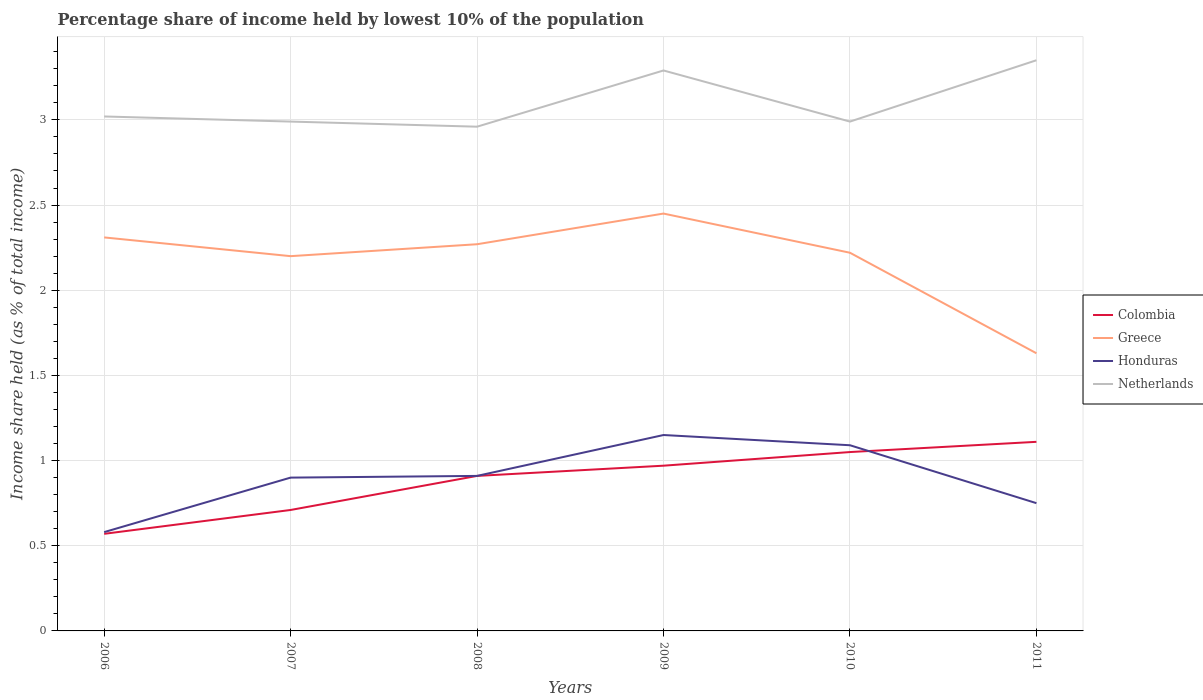Across all years, what is the maximum percentage share of income held by lowest 10% of the population in Colombia?
Make the answer very short. 0.57. What is the total percentage share of income held by lowest 10% of the population in Netherlands in the graph?
Provide a succinct answer. -0.36. What is the difference between the highest and the second highest percentage share of income held by lowest 10% of the population in Greece?
Give a very brief answer. 0.82. What is the difference between two consecutive major ticks on the Y-axis?
Keep it short and to the point. 0.5. Are the values on the major ticks of Y-axis written in scientific E-notation?
Provide a short and direct response. No. Does the graph contain any zero values?
Your response must be concise. No. Where does the legend appear in the graph?
Give a very brief answer. Center right. How many legend labels are there?
Make the answer very short. 4. What is the title of the graph?
Offer a very short reply. Percentage share of income held by lowest 10% of the population. What is the label or title of the Y-axis?
Your response must be concise. Income share held (as % of total income). What is the Income share held (as % of total income) of Colombia in 2006?
Offer a very short reply. 0.57. What is the Income share held (as % of total income) in Greece in 2006?
Offer a terse response. 2.31. What is the Income share held (as % of total income) in Honduras in 2006?
Your answer should be very brief. 0.58. What is the Income share held (as % of total income) in Netherlands in 2006?
Offer a very short reply. 3.02. What is the Income share held (as % of total income) of Colombia in 2007?
Offer a very short reply. 0.71. What is the Income share held (as % of total income) of Greece in 2007?
Make the answer very short. 2.2. What is the Income share held (as % of total income) in Netherlands in 2007?
Ensure brevity in your answer.  2.99. What is the Income share held (as % of total income) in Colombia in 2008?
Provide a succinct answer. 0.91. What is the Income share held (as % of total income) in Greece in 2008?
Provide a short and direct response. 2.27. What is the Income share held (as % of total income) in Honduras in 2008?
Give a very brief answer. 0.91. What is the Income share held (as % of total income) of Netherlands in 2008?
Your answer should be compact. 2.96. What is the Income share held (as % of total income) in Greece in 2009?
Keep it short and to the point. 2.45. What is the Income share held (as % of total income) of Honduras in 2009?
Offer a terse response. 1.15. What is the Income share held (as % of total income) of Netherlands in 2009?
Offer a terse response. 3.29. What is the Income share held (as % of total income) of Greece in 2010?
Keep it short and to the point. 2.22. What is the Income share held (as % of total income) in Honduras in 2010?
Your response must be concise. 1.09. What is the Income share held (as % of total income) of Netherlands in 2010?
Keep it short and to the point. 2.99. What is the Income share held (as % of total income) of Colombia in 2011?
Your answer should be compact. 1.11. What is the Income share held (as % of total income) of Greece in 2011?
Make the answer very short. 1.63. What is the Income share held (as % of total income) of Netherlands in 2011?
Your answer should be compact. 3.35. Across all years, what is the maximum Income share held (as % of total income) of Colombia?
Your answer should be compact. 1.11. Across all years, what is the maximum Income share held (as % of total income) of Greece?
Offer a terse response. 2.45. Across all years, what is the maximum Income share held (as % of total income) in Honduras?
Offer a very short reply. 1.15. Across all years, what is the maximum Income share held (as % of total income) in Netherlands?
Offer a very short reply. 3.35. Across all years, what is the minimum Income share held (as % of total income) of Colombia?
Make the answer very short. 0.57. Across all years, what is the minimum Income share held (as % of total income) in Greece?
Offer a terse response. 1.63. Across all years, what is the minimum Income share held (as % of total income) of Honduras?
Make the answer very short. 0.58. Across all years, what is the minimum Income share held (as % of total income) in Netherlands?
Your answer should be compact. 2.96. What is the total Income share held (as % of total income) in Colombia in the graph?
Provide a short and direct response. 5.32. What is the total Income share held (as % of total income) in Greece in the graph?
Your response must be concise. 13.08. What is the total Income share held (as % of total income) in Honduras in the graph?
Give a very brief answer. 5.38. What is the total Income share held (as % of total income) of Netherlands in the graph?
Give a very brief answer. 18.6. What is the difference between the Income share held (as % of total income) of Colombia in 2006 and that in 2007?
Provide a short and direct response. -0.14. What is the difference between the Income share held (as % of total income) in Greece in 2006 and that in 2007?
Give a very brief answer. 0.11. What is the difference between the Income share held (as % of total income) in Honduras in 2006 and that in 2007?
Your answer should be compact. -0.32. What is the difference between the Income share held (as % of total income) in Netherlands in 2006 and that in 2007?
Your response must be concise. 0.03. What is the difference between the Income share held (as % of total income) of Colombia in 2006 and that in 2008?
Offer a very short reply. -0.34. What is the difference between the Income share held (as % of total income) in Honduras in 2006 and that in 2008?
Your answer should be very brief. -0.33. What is the difference between the Income share held (as % of total income) of Netherlands in 2006 and that in 2008?
Ensure brevity in your answer.  0.06. What is the difference between the Income share held (as % of total income) of Greece in 2006 and that in 2009?
Your response must be concise. -0.14. What is the difference between the Income share held (as % of total income) of Honduras in 2006 and that in 2009?
Offer a terse response. -0.57. What is the difference between the Income share held (as % of total income) of Netherlands in 2006 and that in 2009?
Provide a succinct answer. -0.27. What is the difference between the Income share held (as % of total income) in Colombia in 2006 and that in 2010?
Your answer should be compact. -0.48. What is the difference between the Income share held (as % of total income) in Greece in 2006 and that in 2010?
Your answer should be compact. 0.09. What is the difference between the Income share held (as % of total income) in Honduras in 2006 and that in 2010?
Ensure brevity in your answer.  -0.51. What is the difference between the Income share held (as % of total income) in Netherlands in 2006 and that in 2010?
Provide a succinct answer. 0.03. What is the difference between the Income share held (as % of total income) in Colombia in 2006 and that in 2011?
Ensure brevity in your answer.  -0.54. What is the difference between the Income share held (as % of total income) of Greece in 2006 and that in 2011?
Offer a very short reply. 0.68. What is the difference between the Income share held (as % of total income) of Honduras in 2006 and that in 2011?
Keep it short and to the point. -0.17. What is the difference between the Income share held (as % of total income) in Netherlands in 2006 and that in 2011?
Provide a short and direct response. -0.33. What is the difference between the Income share held (as % of total income) of Colombia in 2007 and that in 2008?
Give a very brief answer. -0.2. What is the difference between the Income share held (as % of total income) of Greece in 2007 and that in 2008?
Offer a terse response. -0.07. What is the difference between the Income share held (as % of total income) of Honduras in 2007 and that in 2008?
Offer a terse response. -0.01. What is the difference between the Income share held (as % of total income) of Netherlands in 2007 and that in 2008?
Your answer should be compact. 0.03. What is the difference between the Income share held (as % of total income) of Colombia in 2007 and that in 2009?
Your answer should be very brief. -0.26. What is the difference between the Income share held (as % of total income) of Honduras in 2007 and that in 2009?
Provide a succinct answer. -0.25. What is the difference between the Income share held (as % of total income) of Netherlands in 2007 and that in 2009?
Your response must be concise. -0.3. What is the difference between the Income share held (as % of total income) of Colombia in 2007 and that in 2010?
Offer a very short reply. -0.34. What is the difference between the Income share held (as % of total income) in Greece in 2007 and that in 2010?
Make the answer very short. -0.02. What is the difference between the Income share held (as % of total income) in Honduras in 2007 and that in 2010?
Make the answer very short. -0.19. What is the difference between the Income share held (as % of total income) in Netherlands in 2007 and that in 2010?
Your response must be concise. 0. What is the difference between the Income share held (as % of total income) of Greece in 2007 and that in 2011?
Ensure brevity in your answer.  0.57. What is the difference between the Income share held (as % of total income) in Honduras in 2007 and that in 2011?
Give a very brief answer. 0.15. What is the difference between the Income share held (as % of total income) in Netherlands in 2007 and that in 2011?
Ensure brevity in your answer.  -0.36. What is the difference between the Income share held (as % of total income) of Colombia in 2008 and that in 2009?
Ensure brevity in your answer.  -0.06. What is the difference between the Income share held (as % of total income) in Greece in 2008 and that in 2009?
Keep it short and to the point. -0.18. What is the difference between the Income share held (as % of total income) of Honduras in 2008 and that in 2009?
Your answer should be compact. -0.24. What is the difference between the Income share held (as % of total income) of Netherlands in 2008 and that in 2009?
Offer a very short reply. -0.33. What is the difference between the Income share held (as % of total income) of Colombia in 2008 and that in 2010?
Keep it short and to the point. -0.14. What is the difference between the Income share held (as % of total income) in Honduras in 2008 and that in 2010?
Provide a short and direct response. -0.18. What is the difference between the Income share held (as % of total income) in Netherlands in 2008 and that in 2010?
Your response must be concise. -0.03. What is the difference between the Income share held (as % of total income) of Greece in 2008 and that in 2011?
Make the answer very short. 0.64. What is the difference between the Income share held (as % of total income) in Honduras in 2008 and that in 2011?
Provide a short and direct response. 0.16. What is the difference between the Income share held (as % of total income) in Netherlands in 2008 and that in 2011?
Keep it short and to the point. -0.39. What is the difference between the Income share held (as % of total income) of Colombia in 2009 and that in 2010?
Make the answer very short. -0.08. What is the difference between the Income share held (as % of total income) in Greece in 2009 and that in 2010?
Your answer should be compact. 0.23. What is the difference between the Income share held (as % of total income) of Honduras in 2009 and that in 2010?
Offer a terse response. 0.06. What is the difference between the Income share held (as % of total income) in Netherlands in 2009 and that in 2010?
Offer a terse response. 0.3. What is the difference between the Income share held (as % of total income) of Colombia in 2009 and that in 2011?
Ensure brevity in your answer.  -0.14. What is the difference between the Income share held (as % of total income) in Greece in 2009 and that in 2011?
Make the answer very short. 0.82. What is the difference between the Income share held (as % of total income) of Netherlands in 2009 and that in 2011?
Give a very brief answer. -0.06. What is the difference between the Income share held (as % of total income) of Colombia in 2010 and that in 2011?
Make the answer very short. -0.06. What is the difference between the Income share held (as % of total income) of Greece in 2010 and that in 2011?
Your answer should be very brief. 0.59. What is the difference between the Income share held (as % of total income) of Honduras in 2010 and that in 2011?
Provide a short and direct response. 0.34. What is the difference between the Income share held (as % of total income) in Netherlands in 2010 and that in 2011?
Offer a very short reply. -0.36. What is the difference between the Income share held (as % of total income) in Colombia in 2006 and the Income share held (as % of total income) in Greece in 2007?
Offer a very short reply. -1.63. What is the difference between the Income share held (as % of total income) in Colombia in 2006 and the Income share held (as % of total income) in Honduras in 2007?
Offer a very short reply. -0.33. What is the difference between the Income share held (as % of total income) of Colombia in 2006 and the Income share held (as % of total income) of Netherlands in 2007?
Your answer should be compact. -2.42. What is the difference between the Income share held (as % of total income) in Greece in 2006 and the Income share held (as % of total income) in Honduras in 2007?
Provide a succinct answer. 1.41. What is the difference between the Income share held (as % of total income) of Greece in 2006 and the Income share held (as % of total income) of Netherlands in 2007?
Provide a short and direct response. -0.68. What is the difference between the Income share held (as % of total income) in Honduras in 2006 and the Income share held (as % of total income) in Netherlands in 2007?
Provide a short and direct response. -2.41. What is the difference between the Income share held (as % of total income) in Colombia in 2006 and the Income share held (as % of total income) in Honduras in 2008?
Offer a terse response. -0.34. What is the difference between the Income share held (as % of total income) in Colombia in 2006 and the Income share held (as % of total income) in Netherlands in 2008?
Provide a succinct answer. -2.39. What is the difference between the Income share held (as % of total income) of Greece in 2006 and the Income share held (as % of total income) of Honduras in 2008?
Offer a terse response. 1.4. What is the difference between the Income share held (as % of total income) in Greece in 2006 and the Income share held (as % of total income) in Netherlands in 2008?
Ensure brevity in your answer.  -0.65. What is the difference between the Income share held (as % of total income) in Honduras in 2006 and the Income share held (as % of total income) in Netherlands in 2008?
Offer a terse response. -2.38. What is the difference between the Income share held (as % of total income) of Colombia in 2006 and the Income share held (as % of total income) of Greece in 2009?
Offer a terse response. -1.88. What is the difference between the Income share held (as % of total income) in Colombia in 2006 and the Income share held (as % of total income) in Honduras in 2009?
Offer a very short reply. -0.58. What is the difference between the Income share held (as % of total income) of Colombia in 2006 and the Income share held (as % of total income) of Netherlands in 2009?
Provide a succinct answer. -2.72. What is the difference between the Income share held (as % of total income) of Greece in 2006 and the Income share held (as % of total income) of Honduras in 2009?
Offer a terse response. 1.16. What is the difference between the Income share held (as % of total income) of Greece in 2006 and the Income share held (as % of total income) of Netherlands in 2009?
Provide a short and direct response. -0.98. What is the difference between the Income share held (as % of total income) in Honduras in 2006 and the Income share held (as % of total income) in Netherlands in 2009?
Provide a succinct answer. -2.71. What is the difference between the Income share held (as % of total income) of Colombia in 2006 and the Income share held (as % of total income) of Greece in 2010?
Offer a very short reply. -1.65. What is the difference between the Income share held (as % of total income) of Colombia in 2006 and the Income share held (as % of total income) of Honduras in 2010?
Your response must be concise. -0.52. What is the difference between the Income share held (as % of total income) in Colombia in 2006 and the Income share held (as % of total income) in Netherlands in 2010?
Keep it short and to the point. -2.42. What is the difference between the Income share held (as % of total income) of Greece in 2006 and the Income share held (as % of total income) of Honduras in 2010?
Your response must be concise. 1.22. What is the difference between the Income share held (as % of total income) in Greece in 2006 and the Income share held (as % of total income) in Netherlands in 2010?
Offer a very short reply. -0.68. What is the difference between the Income share held (as % of total income) of Honduras in 2006 and the Income share held (as % of total income) of Netherlands in 2010?
Provide a short and direct response. -2.41. What is the difference between the Income share held (as % of total income) of Colombia in 2006 and the Income share held (as % of total income) of Greece in 2011?
Offer a terse response. -1.06. What is the difference between the Income share held (as % of total income) of Colombia in 2006 and the Income share held (as % of total income) of Honduras in 2011?
Offer a very short reply. -0.18. What is the difference between the Income share held (as % of total income) of Colombia in 2006 and the Income share held (as % of total income) of Netherlands in 2011?
Offer a very short reply. -2.78. What is the difference between the Income share held (as % of total income) in Greece in 2006 and the Income share held (as % of total income) in Honduras in 2011?
Your answer should be compact. 1.56. What is the difference between the Income share held (as % of total income) in Greece in 2006 and the Income share held (as % of total income) in Netherlands in 2011?
Offer a very short reply. -1.04. What is the difference between the Income share held (as % of total income) of Honduras in 2006 and the Income share held (as % of total income) of Netherlands in 2011?
Your answer should be very brief. -2.77. What is the difference between the Income share held (as % of total income) in Colombia in 2007 and the Income share held (as % of total income) in Greece in 2008?
Make the answer very short. -1.56. What is the difference between the Income share held (as % of total income) of Colombia in 2007 and the Income share held (as % of total income) of Honduras in 2008?
Give a very brief answer. -0.2. What is the difference between the Income share held (as % of total income) in Colombia in 2007 and the Income share held (as % of total income) in Netherlands in 2008?
Offer a terse response. -2.25. What is the difference between the Income share held (as % of total income) of Greece in 2007 and the Income share held (as % of total income) of Honduras in 2008?
Ensure brevity in your answer.  1.29. What is the difference between the Income share held (as % of total income) in Greece in 2007 and the Income share held (as % of total income) in Netherlands in 2008?
Provide a short and direct response. -0.76. What is the difference between the Income share held (as % of total income) of Honduras in 2007 and the Income share held (as % of total income) of Netherlands in 2008?
Keep it short and to the point. -2.06. What is the difference between the Income share held (as % of total income) in Colombia in 2007 and the Income share held (as % of total income) in Greece in 2009?
Give a very brief answer. -1.74. What is the difference between the Income share held (as % of total income) of Colombia in 2007 and the Income share held (as % of total income) of Honduras in 2009?
Keep it short and to the point. -0.44. What is the difference between the Income share held (as % of total income) in Colombia in 2007 and the Income share held (as % of total income) in Netherlands in 2009?
Provide a short and direct response. -2.58. What is the difference between the Income share held (as % of total income) in Greece in 2007 and the Income share held (as % of total income) in Honduras in 2009?
Your response must be concise. 1.05. What is the difference between the Income share held (as % of total income) of Greece in 2007 and the Income share held (as % of total income) of Netherlands in 2009?
Offer a very short reply. -1.09. What is the difference between the Income share held (as % of total income) in Honduras in 2007 and the Income share held (as % of total income) in Netherlands in 2009?
Your answer should be very brief. -2.39. What is the difference between the Income share held (as % of total income) of Colombia in 2007 and the Income share held (as % of total income) of Greece in 2010?
Provide a short and direct response. -1.51. What is the difference between the Income share held (as % of total income) in Colombia in 2007 and the Income share held (as % of total income) in Honduras in 2010?
Ensure brevity in your answer.  -0.38. What is the difference between the Income share held (as % of total income) in Colombia in 2007 and the Income share held (as % of total income) in Netherlands in 2010?
Your answer should be compact. -2.28. What is the difference between the Income share held (as % of total income) of Greece in 2007 and the Income share held (as % of total income) of Honduras in 2010?
Your response must be concise. 1.11. What is the difference between the Income share held (as % of total income) of Greece in 2007 and the Income share held (as % of total income) of Netherlands in 2010?
Offer a terse response. -0.79. What is the difference between the Income share held (as % of total income) in Honduras in 2007 and the Income share held (as % of total income) in Netherlands in 2010?
Offer a very short reply. -2.09. What is the difference between the Income share held (as % of total income) in Colombia in 2007 and the Income share held (as % of total income) in Greece in 2011?
Your answer should be very brief. -0.92. What is the difference between the Income share held (as % of total income) in Colombia in 2007 and the Income share held (as % of total income) in Honduras in 2011?
Provide a succinct answer. -0.04. What is the difference between the Income share held (as % of total income) of Colombia in 2007 and the Income share held (as % of total income) of Netherlands in 2011?
Offer a very short reply. -2.64. What is the difference between the Income share held (as % of total income) in Greece in 2007 and the Income share held (as % of total income) in Honduras in 2011?
Your answer should be compact. 1.45. What is the difference between the Income share held (as % of total income) in Greece in 2007 and the Income share held (as % of total income) in Netherlands in 2011?
Make the answer very short. -1.15. What is the difference between the Income share held (as % of total income) of Honduras in 2007 and the Income share held (as % of total income) of Netherlands in 2011?
Keep it short and to the point. -2.45. What is the difference between the Income share held (as % of total income) in Colombia in 2008 and the Income share held (as % of total income) in Greece in 2009?
Ensure brevity in your answer.  -1.54. What is the difference between the Income share held (as % of total income) in Colombia in 2008 and the Income share held (as % of total income) in Honduras in 2009?
Your response must be concise. -0.24. What is the difference between the Income share held (as % of total income) in Colombia in 2008 and the Income share held (as % of total income) in Netherlands in 2009?
Your answer should be very brief. -2.38. What is the difference between the Income share held (as % of total income) in Greece in 2008 and the Income share held (as % of total income) in Honduras in 2009?
Make the answer very short. 1.12. What is the difference between the Income share held (as % of total income) of Greece in 2008 and the Income share held (as % of total income) of Netherlands in 2009?
Provide a succinct answer. -1.02. What is the difference between the Income share held (as % of total income) of Honduras in 2008 and the Income share held (as % of total income) of Netherlands in 2009?
Offer a very short reply. -2.38. What is the difference between the Income share held (as % of total income) of Colombia in 2008 and the Income share held (as % of total income) of Greece in 2010?
Provide a succinct answer. -1.31. What is the difference between the Income share held (as % of total income) in Colombia in 2008 and the Income share held (as % of total income) in Honduras in 2010?
Give a very brief answer. -0.18. What is the difference between the Income share held (as % of total income) in Colombia in 2008 and the Income share held (as % of total income) in Netherlands in 2010?
Your answer should be very brief. -2.08. What is the difference between the Income share held (as % of total income) of Greece in 2008 and the Income share held (as % of total income) of Honduras in 2010?
Make the answer very short. 1.18. What is the difference between the Income share held (as % of total income) in Greece in 2008 and the Income share held (as % of total income) in Netherlands in 2010?
Offer a terse response. -0.72. What is the difference between the Income share held (as % of total income) in Honduras in 2008 and the Income share held (as % of total income) in Netherlands in 2010?
Ensure brevity in your answer.  -2.08. What is the difference between the Income share held (as % of total income) of Colombia in 2008 and the Income share held (as % of total income) of Greece in 2011?
Offer a terse response. -0.72. What is the difference between the Income share held (as % of total income) of Colombia in 2008 and the Income share held (as % of total income) of Honduras in 2011?
Provide a short and direct response. 0.16. What is the difference between the Income share held (as % of total income) in Colombia in 2008 and the Income share held (as % of total income) in Netherlands in 2011?
Offer a very short reply. -2.44. What is the difference between the Income share held (as % of total income) in Greece in 2008 and the Income share held (as % of total income) in Honduras in 2011?
Give a very brief answer. 1.52. What is the difference between the Income share held (as % of total income) in Greece in 2008 and the Income share held (as % of total income) in Netherlands in 2011?
Offer a very short reply. -1.08. What is the difference between the Income share held (as % of total income) in Honduras in 2008 and the Income share held (as % of total income) in Netherlands in 2011?
Make the answer very short. -2.44. What is the difference between the Income share held (as % of total income) in Colombia in 2009 and the Income share held (as % of total income) in Greece in 2010?
Keep it short and to the point. -1.25. What is the difference between the Income share held (as % of total income) of Colombia in 2009 and the Income share held (as % of total income) of Honduras in 2010?
Provide a succinct answer. -0.12. What is the difference between the Income share held (as % of total income) in Colombia in 2009 and the Income share held (as % of total income) in Netherlands in 2010?
Your answer should be compact. -2.02. What is the difference between the Income share held (as % of total income) of Greece in 2009 and the Income share held (as % of total income) of Honduras in 2010?
Offer a very short reply. 1.36. What is the difference between the Income share held (as % of total income) of Greece in 2009 and the Income share held (as % of total income) of Netherlands in 2010?
Provide a short and direct response. -0.54. What is the difference between the Income share held (as % of total income) in Honduras in 2009 and the Income share held (as % of total income) in Netherlands in 2010?
Make the answer very short. -1.84. What is the difference between the Income share held (as % of total income) of Colombia in 2009 and the Income share held (as % of total income) of Greece in 2011?
Offer a very short reply. -0.66. What is the difference between the Income share held (as % of total income) in Colombia in 2009 and the Income share held (as % of total income) in Honduras in 2011?
Your answer should be very brief. 0.22. What is the difference between the Income share held (as % of total income) in Colombia in 2009 and the Income share held (as % of total income) in Netherlands in 2011?
Give a very brief answer. -2.38. What is the difference between the Income share held (as % of total income) in Greece in 2009 and the Income share held (as % of total income) in Netherlands in 2011?
Your response must be concise. -0.9. What is the difference between the Income share held (as % of total income) of Colombia in 2010 and the Income share held (as % of total income) of Greece in 2011?
Provide a short and direct response. -0.58. What is the difference between the Income share held (as % of total income) in Colombia in 2010 and the Income share held (as % of total income) in Netherlands in 2011?
Your response must be concise. -2.3. What is the difference between the Income share held (as % of total income) in Greece in 2010 and the Income share held (as % of total income) in Honduras in 2011?
Offer a very short reply. 1.47. What is the difference between the Income share held (as % of total income) of Greece in 2010 and the Income share held (as % of total income) of Netherlands in 2011?
Keep it short and to the point. -1.13. What is the difference between the Income share held (as % of total income) in Honduras in 2010 and the Income share held (as % of total income) in Netherlands in 2011?
Keep it short and to the point. -2.26. What is the average Income share held (as % of total income) in Colombia per year?
Provide a short and direct response. 0.89. What is the average Income share held (as % of total income) of Greece per year?
Make the answer very short. 2.18. What is the average Income share held (as % of total income) of Honduras per year?
Keep it short and to the point. 0.9. What is the average Income share held (as % of total income) of Netherlands per year?
Give a very brief answer. 3.1. In the year 2006, what is the difference between the Income share held (as % of total income) in Colombia and Income share held (as % of total income) in Greece?
Provide a short and direct response. -1.74. In the year 2006, what is the difference between the Income share held (as % of total income) in Colombia and Income share held (as % of total income) in Honduras?
Offer a terse response. -0.01. In the year 2006, what is the difference between the Income share held (as % of total income) in Colombia and Income share held (as % of total income) in Netherlands?
Offer a terse response. -2.45. In the year 2006, what is the difference between the Income share held (as % of total income) of Greece and Income share held (as % of total income) of Honduras?
Your answer should be very brief. 1.73. In the year 2006, what is the difference between the Income share held (as % of total income) of Greece and Income share held (as % of total income) of Netherlands?
Provide a short and direct response. -0.71. In the year 2006, what is the difference between the Income share held (as % of total income) of Honduras and Income share held (as % of total income) of Netherlands?
Your answer should be very brief. -2.44. In the year 2007, what is the difference between the Income share held (as % of total income) in Colombia and Income share held (as % of total income) in Greece?
Ensure brevity in your answer.  -1.49. In the year 2007, what is the difference between the Income share held (as % of total income) of Colombia and Income share held (as % of total income) of Honduras?
Your answer should be compact. -0.19. In the year 2007, what is the difference between the Income share held (as % of total income) in Colombia and Income share held (as % of total income) in Netherlands?
Your answer should be compact. -2.28. In the year 2007, what is the difference between the Income share held (as % of total income) of Greece and Income share held (as % of total income) of Netherlands?
Give a very brief answer. -0.79. In the year 2007, what is the difference between the Income share held (as % of total income) in Honduras and Income share held (as % of total income) in Netherlands?
Give a very brief answer. -2.09. In the year 2008, what is the difference between the Income share held (as % of total income) of Colombia and Income share held (as % of total income) of Greece?
Offer a very short reply. -1.36. In the year 2008, what is the difference between the Income share held (as % of total income) in Colombia and Income share held (as % of total income) in Netherlands?
Keep it short and to the point. -2.05. In the year 2008, what is the difference between the Income share held (as % of total income) in Greece and Income share held (as % of total income) in Honduras?
Your answer should be very brief. 1.36. In the year 2008, what is the difference between the Income share held (as % of total income) in Greece and Income share held (as % of total income) in Netherlands?
Provide a short and direct response. -0.69. In the year 2008, what is the difference between the Income share held (as % of total income) of Honduras and Income share held (as % of total income) of Netherlands?
Provide a succinct answer. -2.05. In the year 2009, what is the difference between the Income share held (as % of total income) of Colombia and Income share held (as % of total income) of Greece?
Keep it short and to the point. -1.48. In the year 2009, what is the difference between the Income share held (as % of total income) in Colombia and Income share held (as % of total income) in Honduras?
Ensure brevity in your answer.  -0.18. In the year 2009, what is the difference between the Income share held (as % of total income) of Colombia and Income share held (as % of total income) of Netherlands?
Your answer should be very brief. -2.32. In the year 2009, what is the difference between the Income share held (as % of total income) of Greece and Income share held (as % of total income) of Netherlands?
Ensure brevity in your answer.  -0.84. In the year 2009, what is the difference between the Income share held (as % of total income) of Honduras and Income share held (as % of total income) of Netherlands?
Your answer should be compact. -2.14. In the year 2010, what is the difference between the Income share held (as % of total income) of Colombia and Income share held (as % of total income) of Greece?
Ensure brevity in your answer.  -1.17. In the year 2010, what is the difference between the Income share held (as % of total income) in Colombia and Income share held (as % of total income) in Honduras?
Make the answer very short. -0.04. In the year 2010, what is the difference between the Income share held (as % of total income) in Colombia and Income share held (as % of total income) in Netherlands?
Provide a short and direct response. -1.94. In the year 2010, what is the difference between the Income share held (as % of total income) of Greece and Income share held (as % of total income) of Honduras?
Provide a short and direct response. 1.13. In the year 2010, what is the difference between the Income share held (as % of total income) in Greece and Income share held (as % of total income) in Netherlands?
Your answer should be compact. -0.77. In the year 2011, what is the difference between the Income share held (as % of total income) of Colombia and Income share held (as % of total income) of Greece?
Provide a short and direct response. -0.52. In the year 2011, what is the difference between the Income share held (as % of total income) of Colombia and Income share held (as % of total income) of Honduras?
Ensure brevity in your answer.  0.36. In the year 2011, what is the difference between the Income share held (as % of total income) in Colombia and Income share held (as % of total income) in Netherlands?
Ensure brevity in your answer.  -2.24. In the year 2011, what is the difference between the Income share held (as % of total income) of Greece and Income share held (as % of total income) of Netherlands?
Give a very brief answer. -1.72. What is the ratio of the Income share held (as % of total income) in Colombia in 2006 to that in 2007?
Ensure brevity in your answer.  0.8. What is the ratio of the Income share held (as % of total income) of Greece in 2006 to that in 2007?
Ensure brevity in your answer.  1.05. What is the ratio of the Income share held (as % of total income) of Honduras in 2006 to that in 2007?
Your answer should be very brief. 0.64. What is the ratio of the Income share held (as % of total income) in Colombia in 2006 to that in 2008?
Your response must be concise. 0.63. What is the ratio of the Income share held (as % of total income) of Greece in 2006 to that in 2008?
Provide a short and direct response. 1.02. What is the ratio of the Income share held (as % of total income) of Honduras in 2006 to that in 2008?
Ensure brevity in your answer.  0.64. What is the ratio of the Income share held (as % of total income) of Netherlands in 2006 to that in 2008?
Keep it short and to the point. 1.02. What is the ratio of the Income share held (as % of total income) of Colombia in 2006 to that in 2009?
Provide a short and direct response. 0.59. What is the ratio of the Income share held (as % of total income) of Greece in 2006 to that in 2009?
Offer a very short reply. 0.94. What is the ratio of the Income share held (as % of total income) of Honduras in 2006 to that in 2009?
Offer a terse response. 0.5. What is the ratio of the Income share held (as % of total income) in Netherlands in 2006 to that in 2009?
Offer a terse response. 0.92. What is the ratio of the Income share held (as % of total income) in Colombia in 2006 to that in 2010?
Your response must be concise. 0.54. What is the ratio of the Income share held (as % of total income) of Greece in 2006 to that in 2010?
Make the answer very short. 1.04. What is the ratio of the Income share held (as % of total income) in Honduras in 2006 to that in 2010?
Offer a terse response. 0.53. What is the ratio of the Income share held (as % of total income) in Colombia in 2006 to that in 2011?
Offer a very short reply. 0.51. What is the ratio of the Income share held (as % of total income) of Greece in 2006 to that in 2011?
Provide a succinct answer. 1.42. What is the ratio of the Income share held (as % of total income) of Honduras in 2006 to that in 2011?
Give a very brief answer. 0.77. What is the ratio of the Income share held (as % of total income) of Netherlands in 2006 to that in 2011?
Your answer should be very brief. 0.9. What is the ratio of the Income share held (as % of total income) in Colombia in 2007 to that in 2008?
Provide a short and direct response. 0.78. What is the ratio of the Income share held (as % of total income) of Greece in 2007 to that in 2008?
Make the answer very short. 0.97. What is the ratio of the Income share held (as % of total income) in Netherlands in 2007 to that in 2008?
Your answer should be compact. 1.01. What is the ratio of the Income share held (as % of total income) of Colombia in 2007 to that in 2009?
Your response must be concise. 0.73. What is the ratio of the Income share held (as % of total income) of Greece in 2007 to that in 2009?
Ensure brevity in your answer.  0.9. What is the ratio of the Income share held (as % of total income) of Honduras in 2007 to that in 2009?
Keep it short and to the point. 0.78. What is the ratio of the Income share held (as % of total income) in Netherlands in 2007 to that in 2009?
Offer a very short reply. 0.91. What is the ratio of the Income share held (as % of total income) of Colombia in 2007 to that in 2010?
Give a very brief answer. 0.68. What is the ratio of the Income share held (as % of total income) of Greece in 2007 to that in 2010?
Your response must be concise. 0.99. What is the ratio of the Income share held (as % of total income) in Honduras in 2007 to that in 2010?
Provide a short and direct response. 0.83. What is the ratio of the Income share held (as % of total income) in Colombia in 2007 to that in 2011?
Offer a terse response. 0.64. What is the ratio of the Income share held (as % of total income) in Greece in 2007 to that in 2011?
Make the answer very short. 1.35. What is the ratio of the Income share held (as % of total income) in Honduras in 2007 to that in 2011?
Make the answer very short. 1.2. What is the ratio of the Income share held (as % of total income) in Netherlands in 2007 to that in 2011?
Ensure brevity in your answer.  0.89. What is the ratio of the Income share held (as % of total income) in Colombia in 2008 to that in 2009?
Offer a terse response. 0.94. What is the ratio of the Income share held (as % of total income) of Greece in 2008 to that in 2009?
Keep it short and to the point. 0.93. What is the ratio of the Income share held (as % of total income) in Honduras in 2008 to that in 2009?
Your response must be concise. 0.79. What is the ratio of the Income share held (as % of total income) in Netherlands in 2008 to that in 2009?
Make the answer very short. 0.9. What is the ratio of the Income share held (as % of total income) of Colombia in 2008 to that in 2010?
Provide a short and direct response. 0.87. What is the ratio of the Income share held (as % of total income) in Greece in 2008 to that in 2010?
Offer a very short reply. 1.02. What is the ratio of the Income share held (as % of total income) in Honduras in 2008 to that in 2010?
Offer a terse response. 0.83. What is the ratio of the Income share held (as % of total income) in Netherlands in 2008 to that in 2010?
Your answer should be compact. 0.99. What is the ratio of the Income share held (as % of total income) of Colombia in 2008 to that in 2011?
Offer a very short reply. 0.82. What is the ratio of the Income share held (as % of total income) of Greece in 2008 to that in 2011?
Ensure brevity in your answer.  1.39. What is the ratio of the Income share held (as % of total income) of Honduras in 2008 to that in 2011?
Provide a succinct answer. 1.21. What is the ratio of the Income share held (as % of total income) in Netherlands in 2008 to that in 2011?
Your answer should be very brief. 0.88. What is the ratio of the Income share held (as % of total income) in Colombia in 2009 to that in 2010?
Offer a very short reply. 0.92. What is the ratio of the Income share held (as % of total income) in Greece in 2009 to that in 2010?
Provide a succinct answer. 1.1. What is the ratio of the Income share held (as % of total income) of Honduras in 2009 to that in 2010?
Keep it short and to the point. 1.05. What is the ratio of the Income share held (as % of total income) of Netherlands in 2009 to that in 2010?
Keep it short and to the point. 1.1. What is the ratio of the Income share held (as % of total income) in Colombia in 2009 to that in 2011?
Ensure brevity in your answer.  0.87. What is the ratio of the Income share held (as % of total income) in Greece in 2009 to that in 2011?
Offer a very short reply. 1.5. What is the ratio of the Income share held (as % of total income) of Honduras in 2009 to that in 2011?
Provide a succinct answer. 1.53. What is the ratio of the Income share held (as % of total income) in Netherlands in 2009 to that in 2011?
Offer a terse response. 0.98. What is the ratio of the Income share held (as % of total income) of Colombia in 2010 to that in 2011?
Offer a terse response. 0.95. What is the ratio of the Income share held (as % of total income) in Greece in 2010 to that in 2011?
Make the answer very short. 1.36. What is the ratio of the Income share held (as % of total income) of Honduras in 2010 to that in 2011?
Keep it short and to the point. 1.45. What is the ratio of the Income share held (as % of total income) of Netherlands in 2010 to that in 2011?
Offer a terse response. 0.89. What is the difference between the highest and the second highest Income share held (as % of total income) in Colombia?
Give a very brief answer. 0.06. What is the difference between the highest and the second highest Income share held (as % of total income) in Greece?
Provide a succinct answer. 0.14. What is the difference between the highest and the second highest Income share held (as % of total income) of Honduras?
Your answer should be very brief. 0.06. What is the difference between the highest and the lowest Income share held (as % of total income) in Colombia?
Your answer should be very brief. 0.54. What is the difference between the highest and the lowest Income share held (as % of total income) of Greece?
Offer a terse response. 0.82. What is the difference between the highest and the lowest Income share held (as % of total income) of Honduras?
Your answer should be compact. 0.57. What is the difference between the highest and the lowest Income share held (as % of total income) of Netherlands?
Provide a short and direct response. 0.39. 